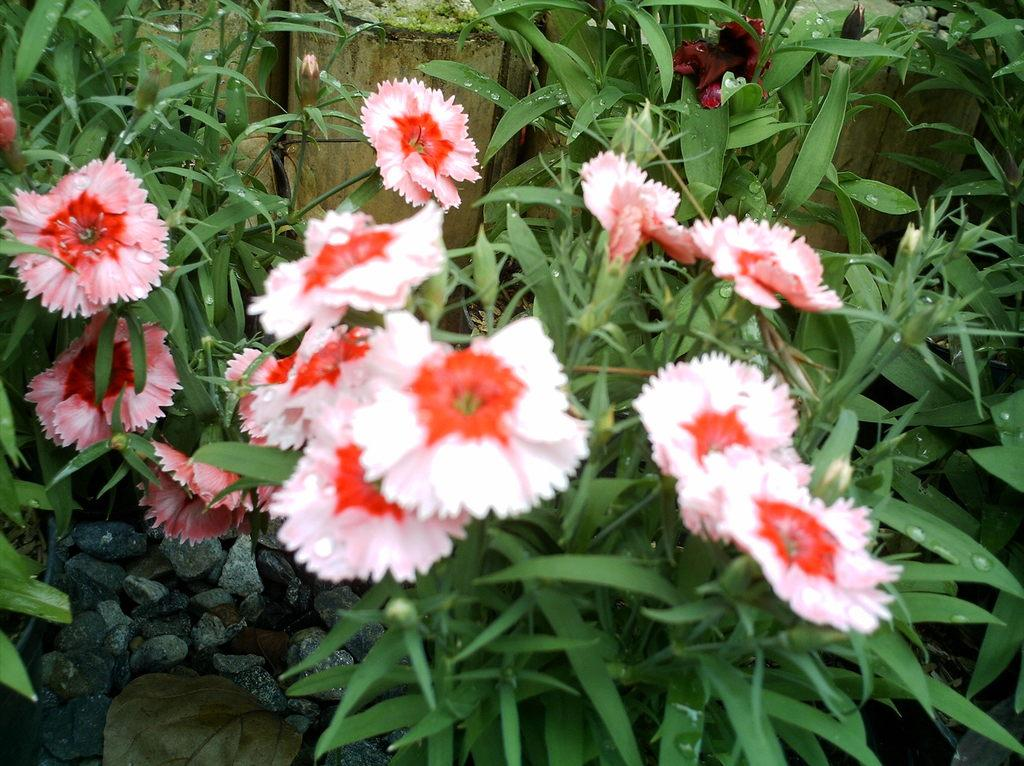What type of plants are present in the image? There are plants with flowers in the image. What color are the flowers on the plants? The flowers are pink in color. What can be seen in the background of the image? There is a wall and grass in the background of the image. What is located at the bottom of the image? There are stones and leaves at the bottom of the image. How much steam is coming off the flowers in the image? There is no steam present in the image; it features plants with flowers, a wall, grass, stones, and leaves. 